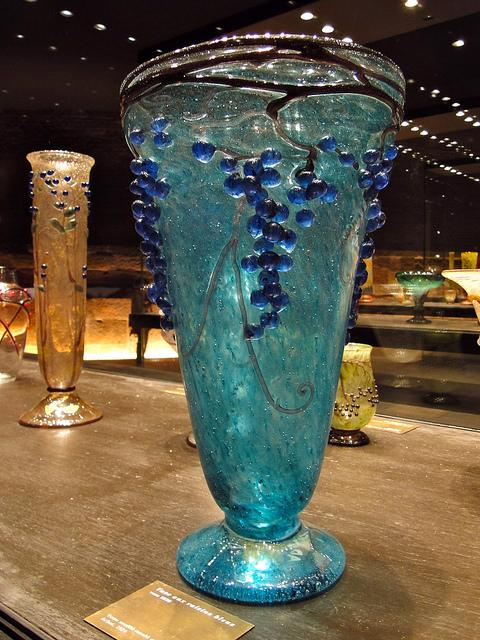What venue is this likely to be?

Choices:
A) art gallery
B) restaurant
C) hotel
D) department store art gallery 